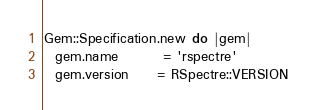Convert code to text. <code><loc_0><loc_0><loc_500><loc_500><_Ruby_>Gem::Specification.new do |gem|
  gem.name        = 'rspectre'
  gem.version     = RSpectre::VERSION</code> 